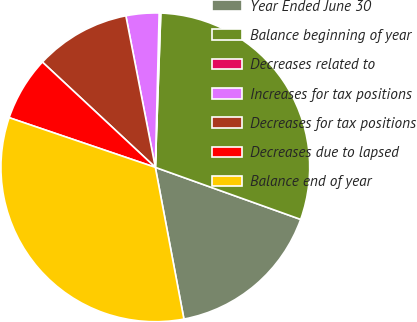<chart> <loc_0><loc_0><loc_500><loc_500><pie_chart><fcel>Year Ended June 30<fcel>Balance beginning of year<fcel>Decreases related to<fcel>Increases for tax positions<fcel>Decreases for tax positions<fcel>Decreases due to lapsed<fcel>Balance end of year<nl><fcel>16.56%<fcel>29.91%<fcel>0.17%<fcel>3.45%<fcel>10.0%<fcel>6.73%<fcel>33.18%<nl></chart> 